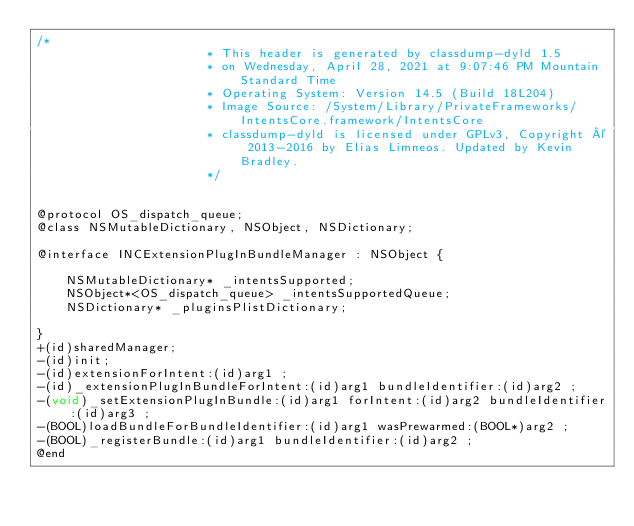Convert code to text. <code><loc_0><loc_0><loc_500><loc_500><_C_>/*
                       * This header is generated by classdump-dyld 1.5
                       * on Wednesday, April 28, 2021 at 9:07:46 PM Mountain Standard Time
                       * Operating System: Version 14.5 (Build 18L204)
                       * Image Source: /System/Library/PrivateFrameworks/IntentsCore.framework/IntentsCore
                       * classdump-dyld is licensed under GPLv3, Copyright © 2013-2016 by Elias Limneos. Updated by Kevin Bradley.
                       */


@protocol OS_dispatch_queue;
@class NSMutableDictionary, NSObject, NSDictionary;

@interface INCExtensionPlugInBundleManager : NSObject {

	NSMutableDictionary* _intentsSupported;
	NSObject*<OS_dispatch_queue> _intentsSupportedQueue;
	NSDictionary* _pluginsPlistDictionary;

}
+(id)sharedManager;
-(id)init;
-(id)extensionForIntent:(id)arg1 ;
-(id)_extensionPlugInBundleForIntent:(id)arg1 bundleIdentifier:(id)arg2 ;
-(void)_setExtensionPlugInBundle:(id)arg1 forIntent:(id)arg2 bundleIdentifier:(id)arg3 ;
-(BOOL)loadBundleForBundleIdentifier:(id)arg1 wasPrewarmed:(BOOL*)arg2 ;
-(BOOL)_registerBundle:(id)arg1 bundleIdentifier:(id)arg2 ;
@end

</code> 